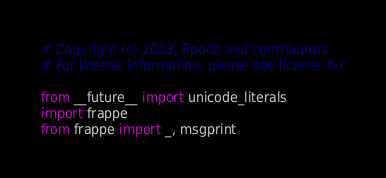Convert code to text. <code><loc_0><loc_0><loc_500><loc_500><_Python_># Copyright (c) 2013, Epoch and contributors
# For license information, please see license.txt

from __future__ import unicode_literals
import frappe
from frappe import _, msgprint</code> 